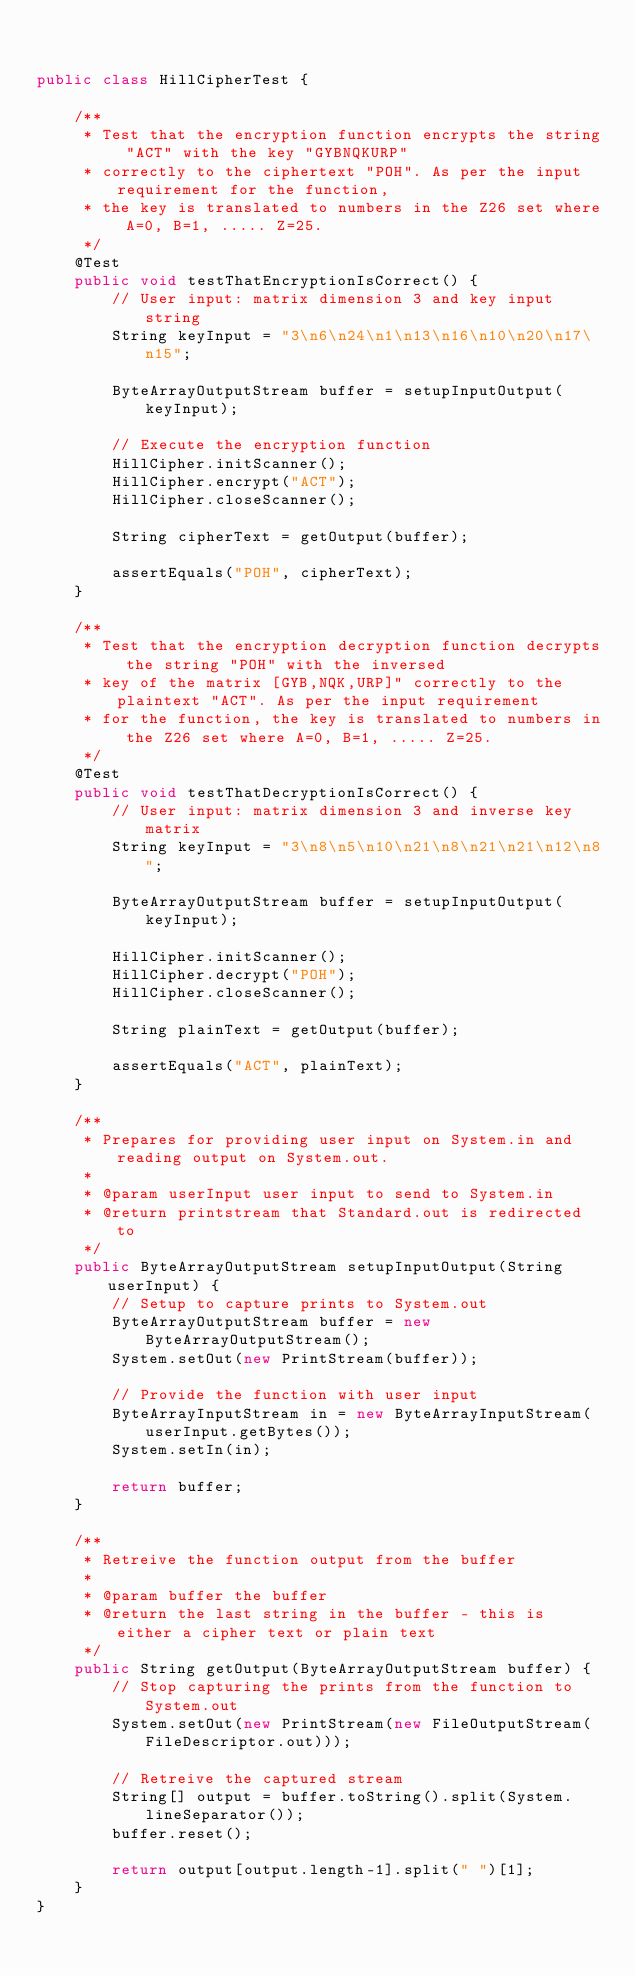<code> <loc_0><loc_0><loc_500><loc_500><_Java_>

public class HillCipherTest {

    /**
     * Test that the encryption function encrypts the string "ACT" with the key "GYBNQKURP" 
     * correctly to the ciphertext "POH". As per the input requirement for the function, 
     * the key is translated to numbers in the Z26 set where A=0, B=1, ..... Z=25. 
     */
    @Test
    public void testThatEncryptionIsCorrect() {
        // User input: matrix dimension 3 and key input string
        String keyInput = "3\n6\n24\n1\n13\n16\n10\n20\n17\n15";

        ByteArrayOutputStream buffer = setupInputOutput(keyInput);

        // Execute the encryption function
        HillCipher.initScanner();
        HillCipher.encrypt("ACT");
        HillCipher.closeScanner();

        String cipherText = getOutput(buffer);

        assertEquals("POH", cipherText);
    }

    /**
     * Test that the encryption decryption function decrypts the string "POH" with the inversed 
     * key of the matrix [GYB,NQK,URP]" correctly to the plaintext "ACT". As per the input requirement 
     * for the function, the key is translated to numbers in the Z26 set where A=0, B=1, ..... Z=25. 
     */
    @Test
    public void testThatDecryptionIsCorrect() {
        // User input: matrix dimension 3 and inverse key matrix
        String keyInput = "3\n8\n5\n10\n21\n8\n21\n21\n12\n8";
        
        ByteArrayOutputStream buffer = setupInputOutput(keyInput);

        HillCipher.initScanner();
        HillCipher.decrypt("POH");
        HillCipher.closeScanner();

        String plainText = getOutput(buffer);
        
        assertEquals("ACT", plainText);
    }

    /**
     * Prepares for providing user input on System.in and reading output on System.out.
     * 
     * @param userInput user input to send to System.in
     * @return printstream that Standard.out is redirected to
     */
    public ByteArrayOutputStream setupInputOutput(String userInput) {
        // Setup to capture prints to System.out 
        ByteArrayOutputStream buffer = new ByteArrayOutputStream();
        System.setOut(new PrintStream(buffer));

        // Provide the function with user input
        ByteArrayInputStream in = new ByteArrayInputStream(userInput.getBytes());
        System.setIn(in);

        return buffer;
    }

    /**
     * Retreive the function output from the buffer
     * 
     * @param buffer the buffer
     * @return the last string in the buffer - this is either a cipher text or plain text
     */
    public String getOutput(ByteArrayOutputStream buffer) {
        // Stop capturing the prints from the function to System.out
        System.setOut(new PrintStream(new FileOutputStream(FileDescriptor.out)));
                
        // Retreive the captured stream
        String[] output = buffer.toString().split(System.lineSeparator());
        buffer.reset();

        return output[output.length-1].split(" ")[1];
    }
}</code> 